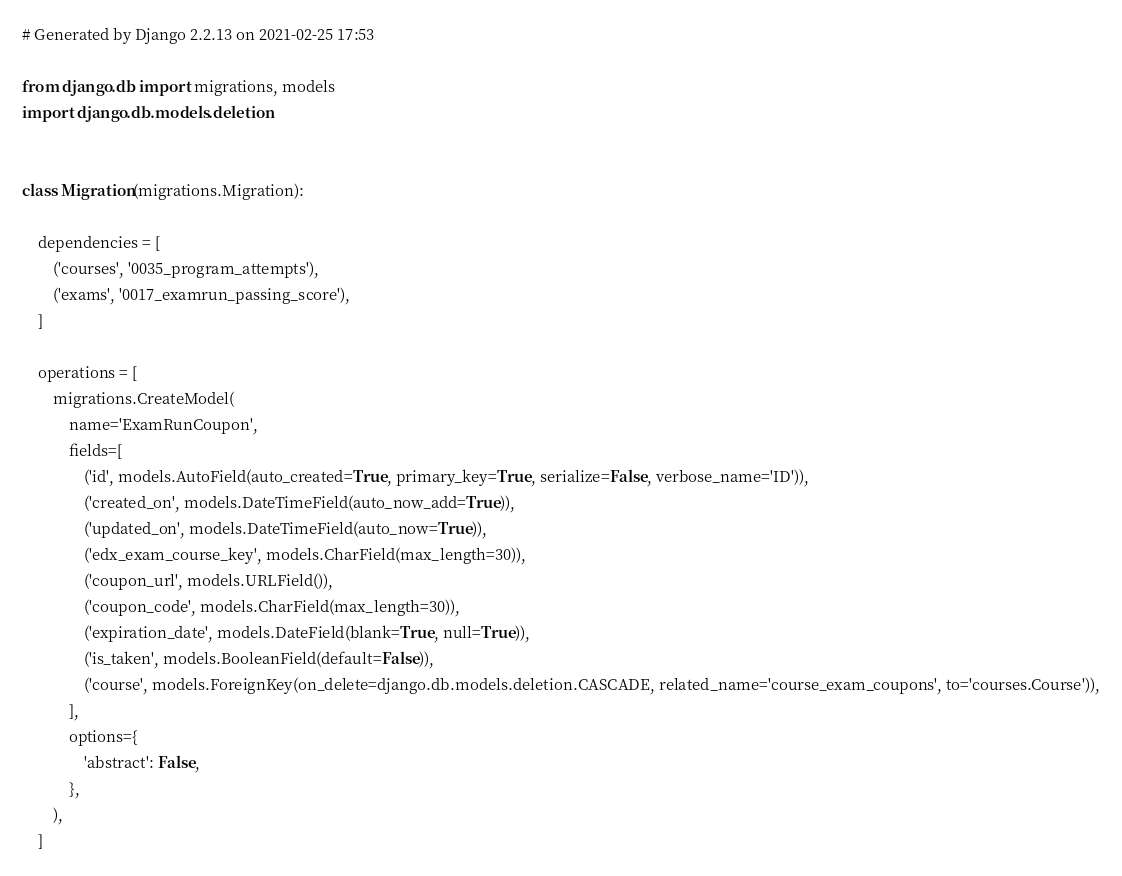<code> <loc_0><loc_0><loc_500><loc_500><_Python_># Generated by Django 2.2.13 on 2021-02-25 17:53

from django.db import migrations, models
import django.db.models.deletion


class Migration(migrations.Migration):

    dependencies = [
        ('courses', '0035_program_attempts'),
        ('exams', '0017_examrun_passing_score'),
    ]

    operations = [
        migrations.CreateModel(
            name='ExamRunCoupon',
            fields=[
                ('id', models.AutoField(auto_created=True, primary_key=True, serialize=False, verbose_name='ID')),
                ('created_on', models.DateTimeField(auto_now_add=True)),
                ('updated_on', models.DateTimeField(auto_now=True)),
                ('edx_exam_course_key', models.CharField(max_length=30)),
                ('coupon_url', models.URLField()),
                ('coupon_code', models.CharField(max_length=30)),
                ('expiration_date', models.DateField(blank=True, null=True)),
                ('is_taken', models.BooleanField(default=False)),
                ('course', models.ForeignKey(on_delete=django.db.models.deletion.CASCADE, related_name='course_exam_coupons', to='courses.Course')),
            ],
            options={
                'abstract': False,
            },
        ),
    ]
</code> 